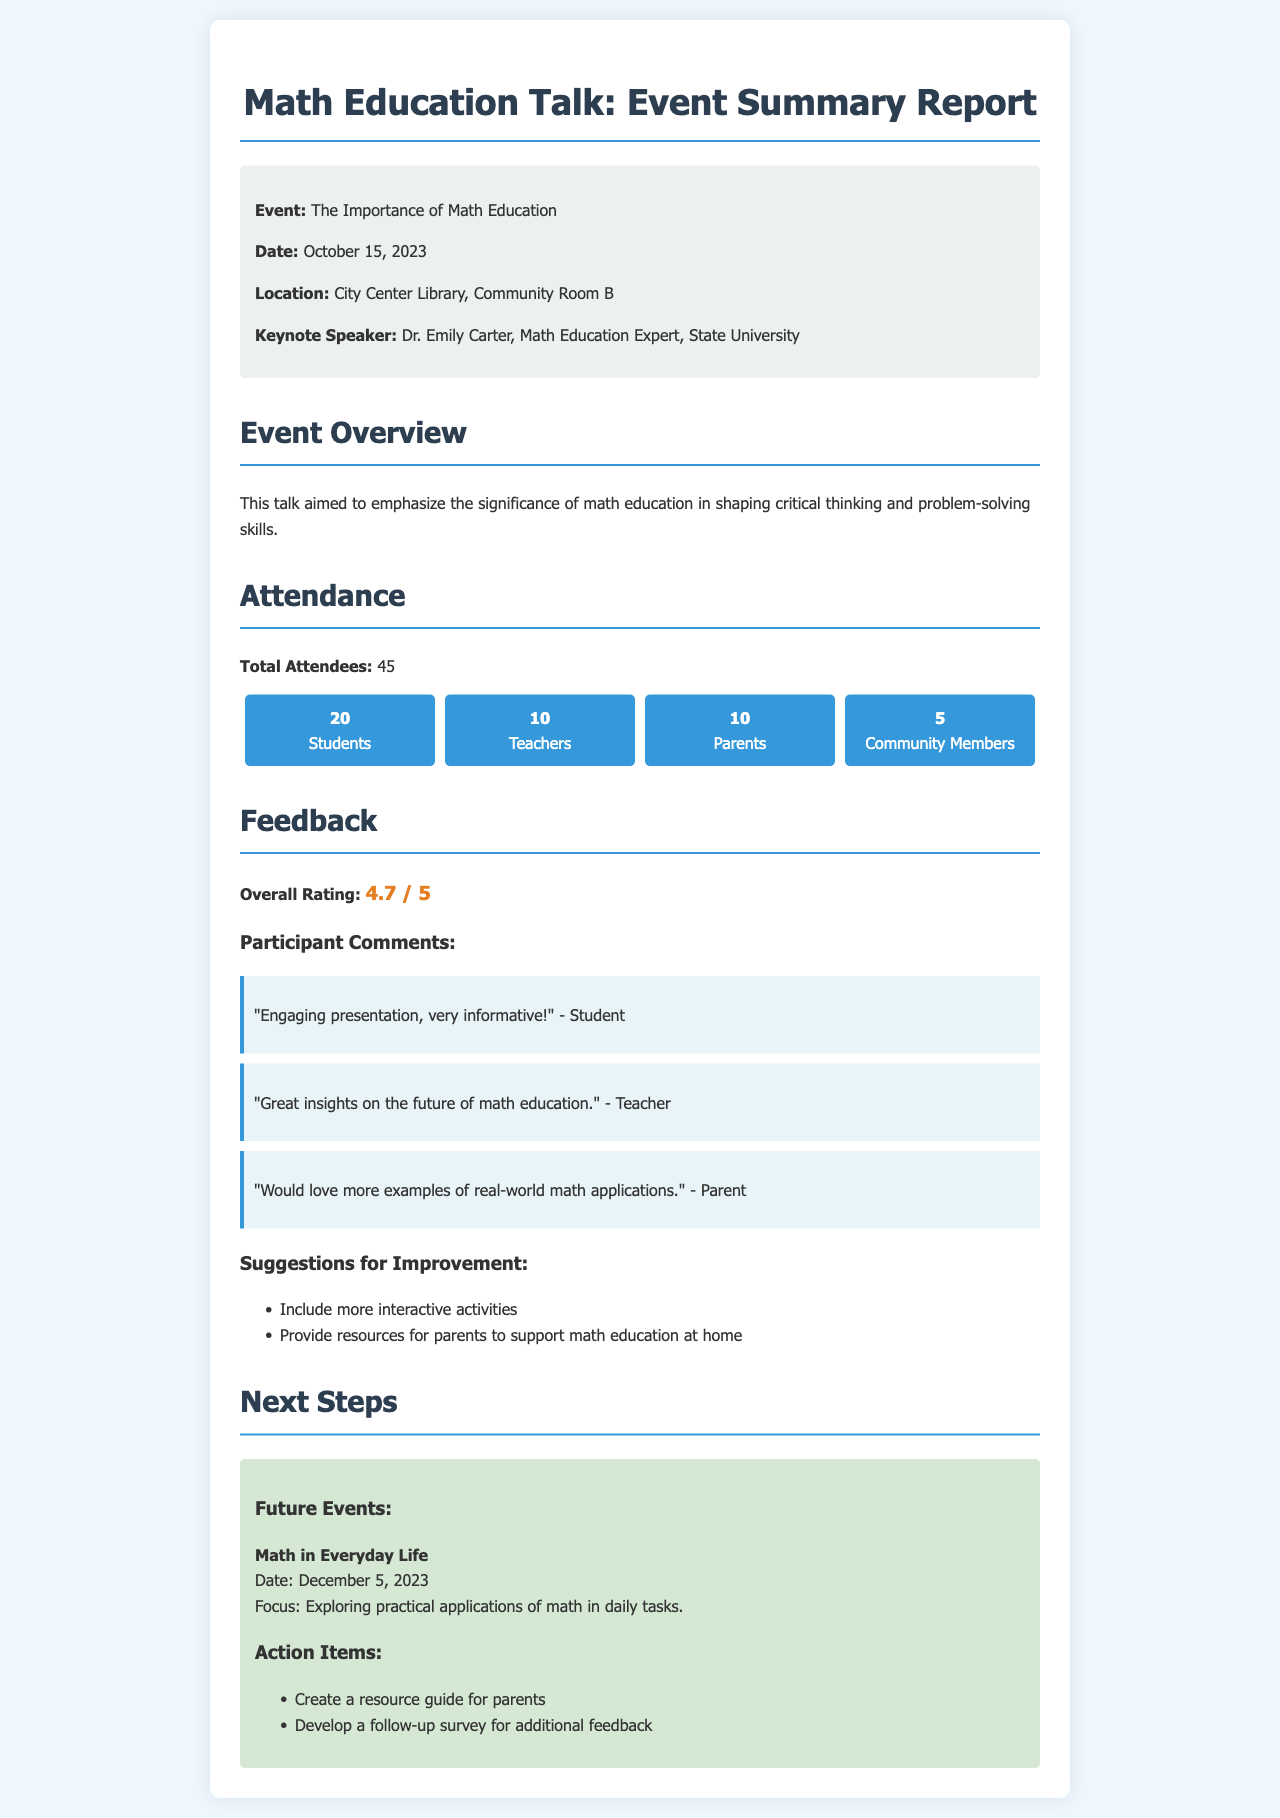What is the event title? The event title is the main topic being discussed in the document, which is mentioned prominently at the beginning.
Answer: The Importance of Math Education Who was the keynote speaker? The keynote speaker's name is specifically highlighted in the event details section.
Answer: Dr. Emily Carter What was the attendance of parents? This number can be found in the attendance breakdown showing the categories of attendees.
Answer: 10 What was the overall rating given by participants? The overall rating is mentioned in the feedback section as a specific value.
Answer: 4.7 / 5 What suggestions were made for improvement? Suggestions for improvement are listed in a bullet point format, highlighting feedback from participants.
Answer: Include more interactive activities How many total attendees were there? This figure is provided directly in the attendance section, summarizing all participants.
Answer: 45 What is the date of the future event? The future event date is mentioned under the next steps section.
Answer: December 5, 2023 What was the focus of the future event? The focus is detailed in the next steps section describing what the future event will explore.
Answer: Exploring practical applications of math in daily tasks 